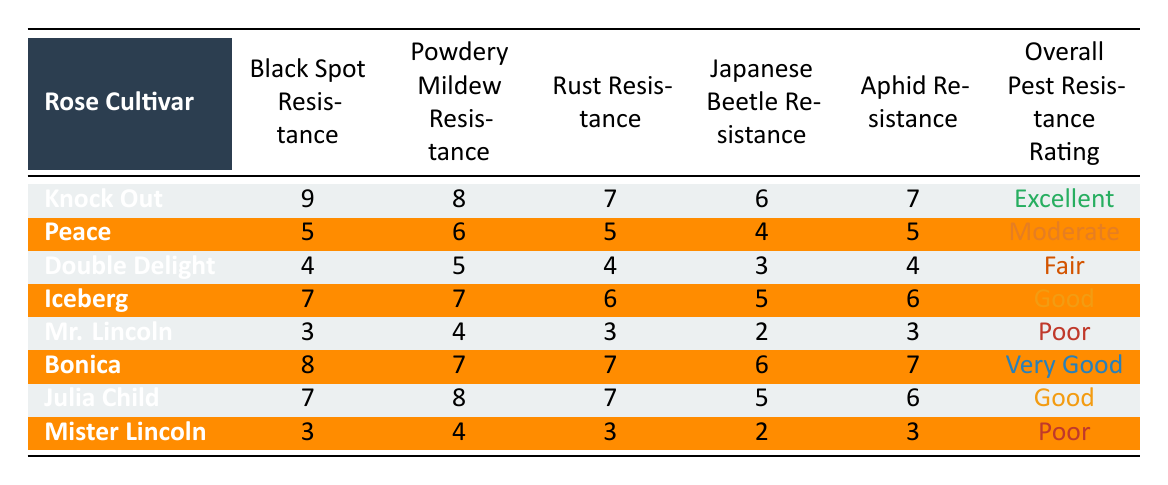What's the Black Spot Resistance rating for the Knock Out rose cultivar? The table lists the Black Spot Resistance rating for Knock Out as 9.
Answer: 9 Which rose cultivar has the highest overall pest resistance rating? The highest overall pest resistance rating listed in the table is "Excellent," which corresponds to the Knock Out cultivar.
Answer: Knock Out Is Peace resistant to Japanese Beetles? The Japanese Beetle Resistance rating for Peace is 4, which indicates a moderate level of resistance. Therefore, it is somewhat resistant.
Answer: Yes What is the average Powdery Mildew Resistance rating of the rose cultivars listed? Summing the Powdery Mildew Resistance values (8 + 6 + 5 + 7 + 4 + 7 + 8 + 4) = 49, and there are 8 cultivars, the average is 49/8 = 6.125.
Answer: 6.125 Which rose cultivars have an Overall Pest Resistance Rating of "Good"? The table shows Iceberg and Julia Child each have an Overall Pest Resistance Rating of "Good."
Answer: Iceberg, Julia Child Is there a rose cultivar that has an Overall Pest Resistance Rating of "Fair" but has high Black Spot Resistance? Double Delight has an Overall Pest Resistance Rating of "Fair" and a Black Spot Resistance rating of just 4, which is not high. Thus, no.
Answer: No How does the resistance of Bonica to Aphids compare to that of Mr. Lincoln? Bonica has an Aphid Resistance rating of 7, while Mr. Lincoln has a rating of 3, indicating Bonica is significantly more resistant than Mr. Lincoln.
Answer: Bonica is more resistant What is the difference in Japanese Beetle Resistance between Julia Child and Iceberg? Julia Child has a Japanese Beetle Resistance of 5, and Iceberg has a rating of 5 as well. Therefore, the difference is 0.
Answer: 0 